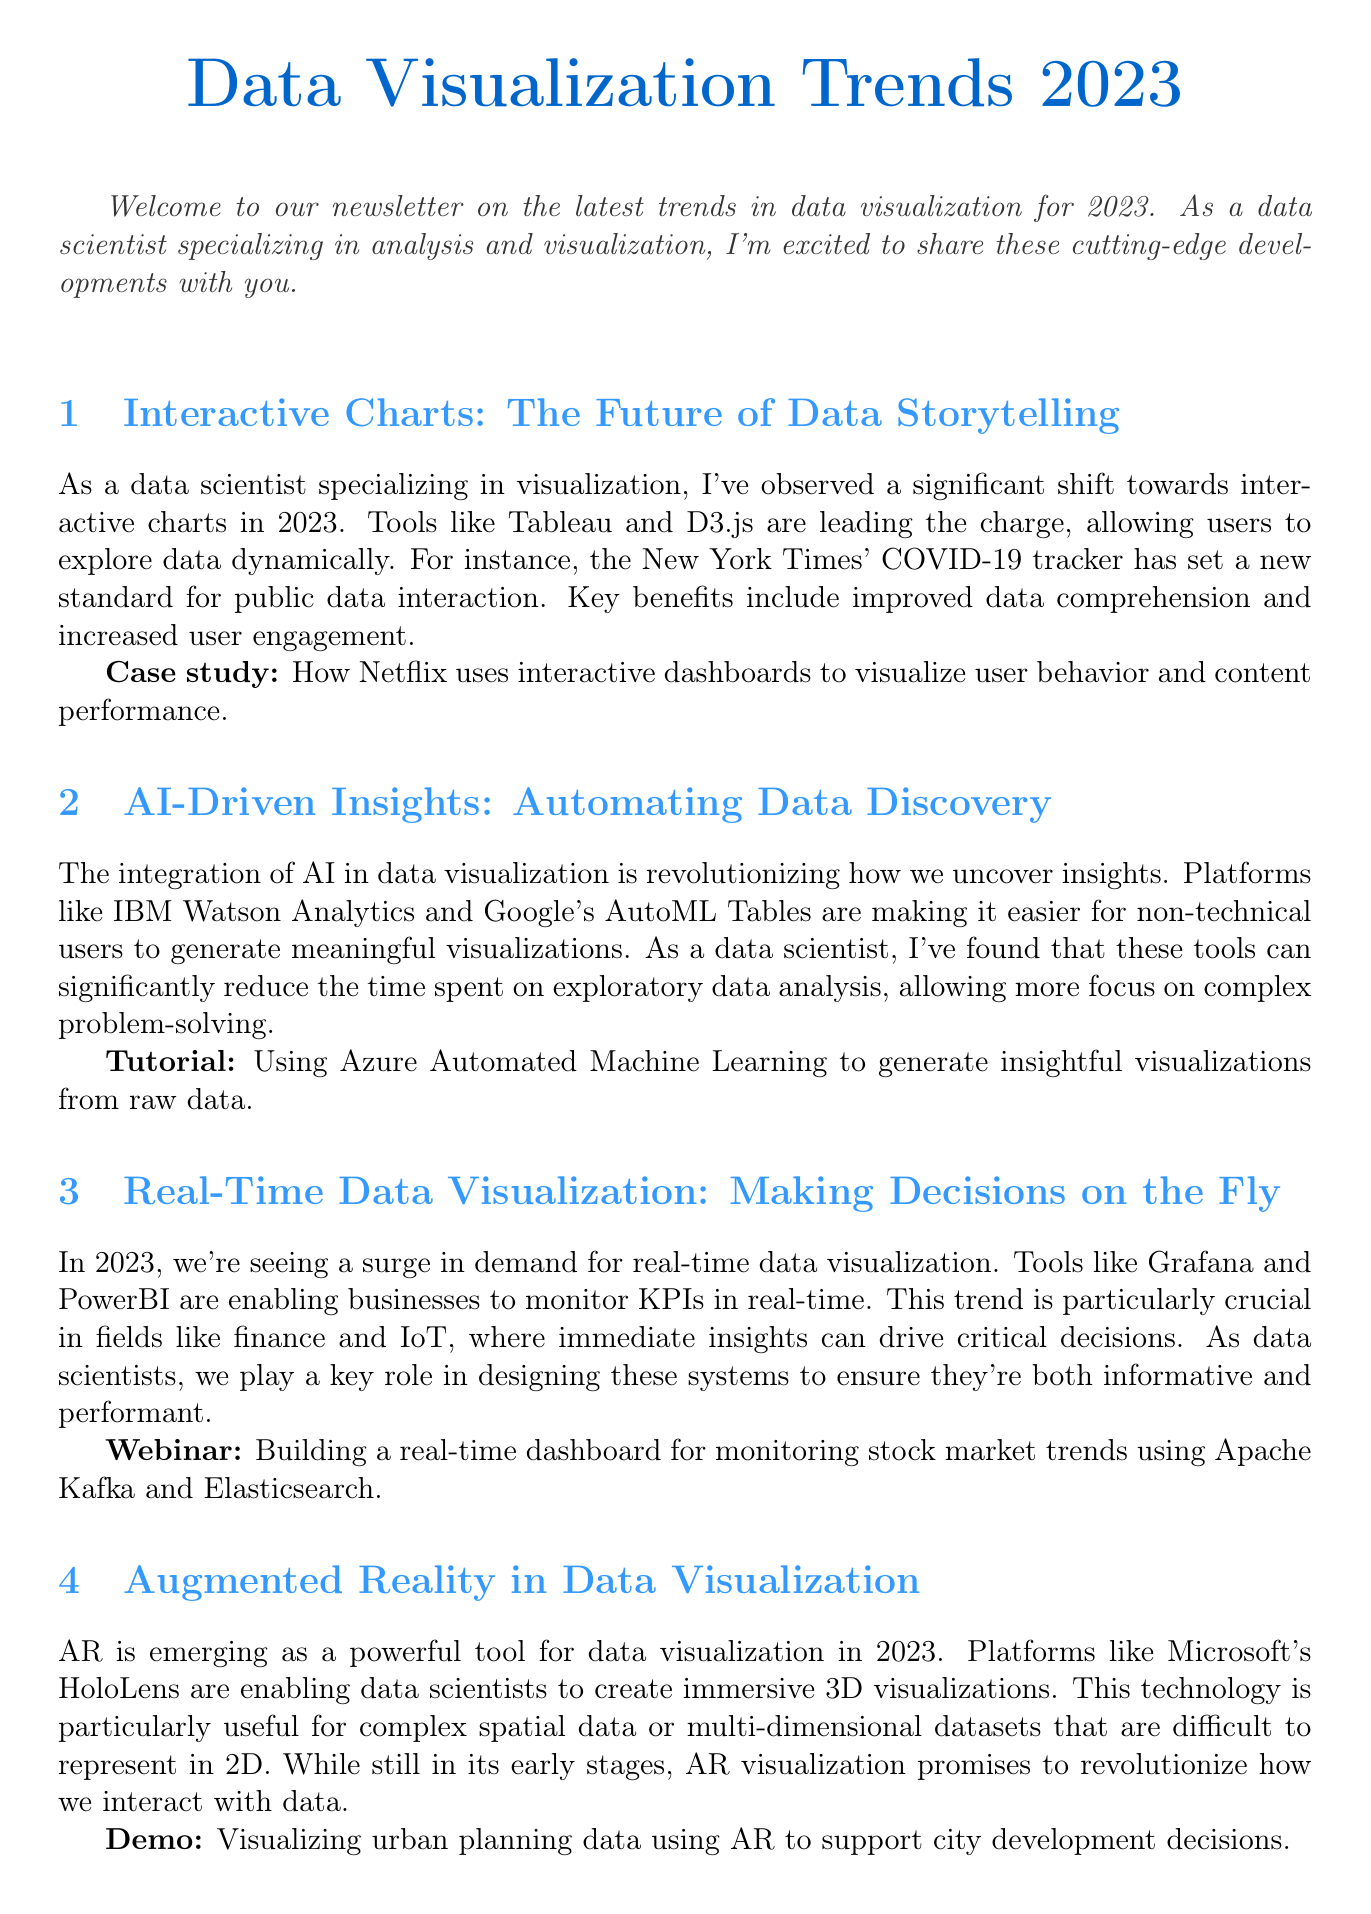What are the tools mentioned for interactive charts? The tools mentioned for interactive charts are Tableau and D3.js.
Answer: Tableau and D3.js What year are the data visualization trends discussed? The newsletter discusses the trends for the year 2023.
Answer: 2023 Which case study highlights interactive dashboards? The case study highlights how Netflix uses interactive dashboards.
Answer: Netflix What is a key benefit of AI-driven insights? A key benefit is reducing the time spent on exploratory data analysis.
Answer: Reducing time on exploratory data analysis Which sector is particularly impacted by real-time data visualization? The finance sector is particularly impacted by real-time data visualization.
Answer: Finance What emerging technology is mentioned for data visualization in 2023? Augmented Reality is mentioned as an emerging technology.
Answer: Augmented Reality What is the primary focus of highcharts according to the document? The primary focus of highcharts is on accessibility features like sonification.
Answer: Accessibility features like sonification What is the call to action of the newsletter? The call to action is to join the upcoming webinar series for hands-on tutorials.
Answer: Join the upcoming webinar series What format does the content suggest for visualizing spatial data? The content suggests using 3D visualizations for spatial data.
Answer: 3D visualizations 